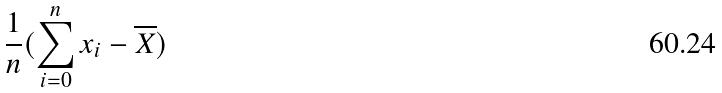Convert formula to latex. <formula><loc_0><loc_0><loc_500><loc_500>\frac { 1 } { n } ( \sum _ { i = 0 } ^ { n } x _ { i } - \overline { X } )</formula> 